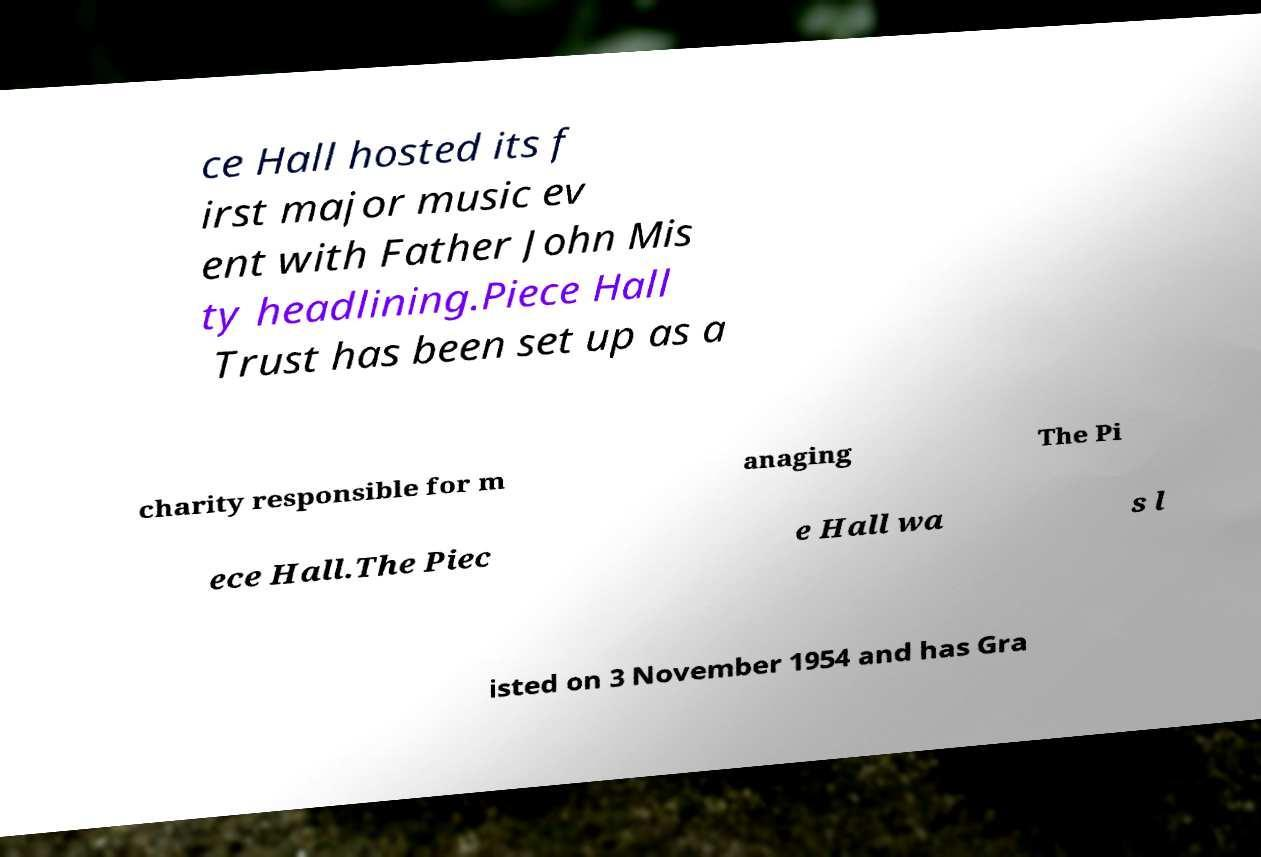Please read and relay the text visible in this image. What does it say? ce Hall hosted its f irst major music ev ent with Father John Mis ty headlining.Piece Hall Trust has been set up as a charity responsible for m anaging The Pi ece Hall.The Piec e Hall wa s l isted on 3 November 1954 and has Gra 